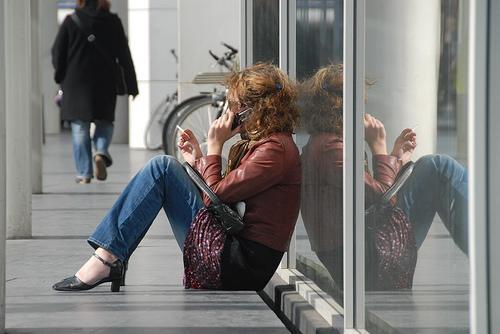How many people are in the photo?
Give a very brief answer. 2. How many pizzas are cooked in the picture?
Give a very brief answer. 0. 